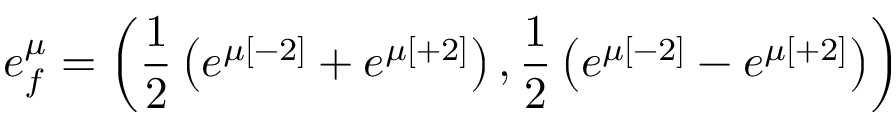<formula> <loc_0><loc_0><loc_500><loc_500>e _ { f } ^ { \mu } = \left ( { \frac { 1 } { 2 } } \left ( e ^ { \mu [ - 2 ] } + e ^ { \mu [ + 2 ] } \right ) , { \frac { 1 } { 2 } } \left ( e ^ { \mu [ - 2 ] } - e ^ { \mu [ + 2 ] } \right ) \right )</formula> 